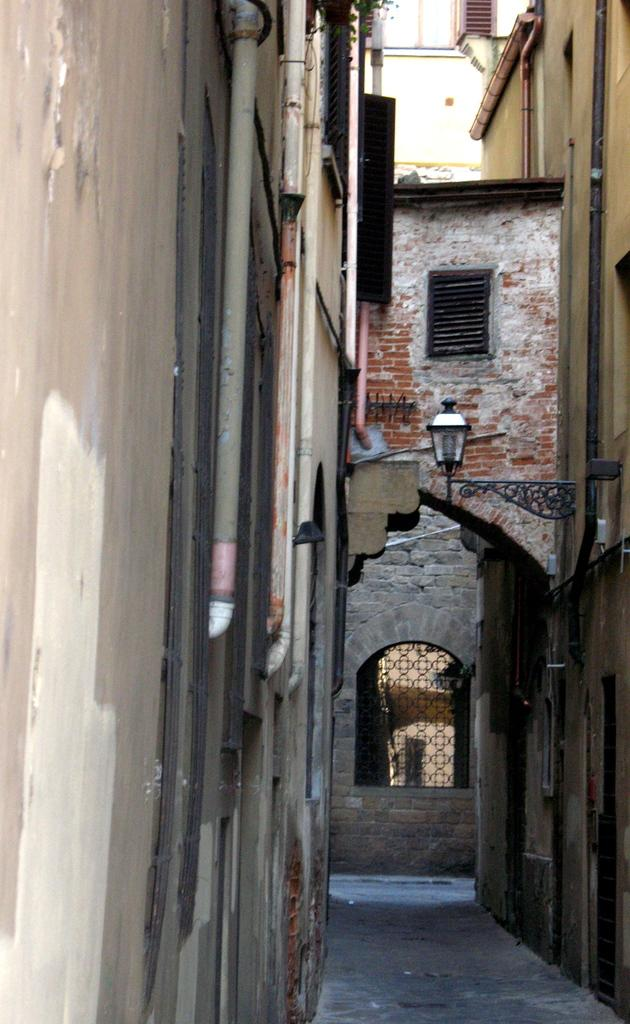What is the main feature in the middle of the image? There is a path in the middle of the image. What can be seen on either side of the path? There are buildings on either side of the path. What is located at the front of the image? There is a wall with windows in the front of the image. How many hands are visible in the image? There are no hands visible in the image. What type of net is used to catch the birds in the image? There are no birds or nets present in the image. 